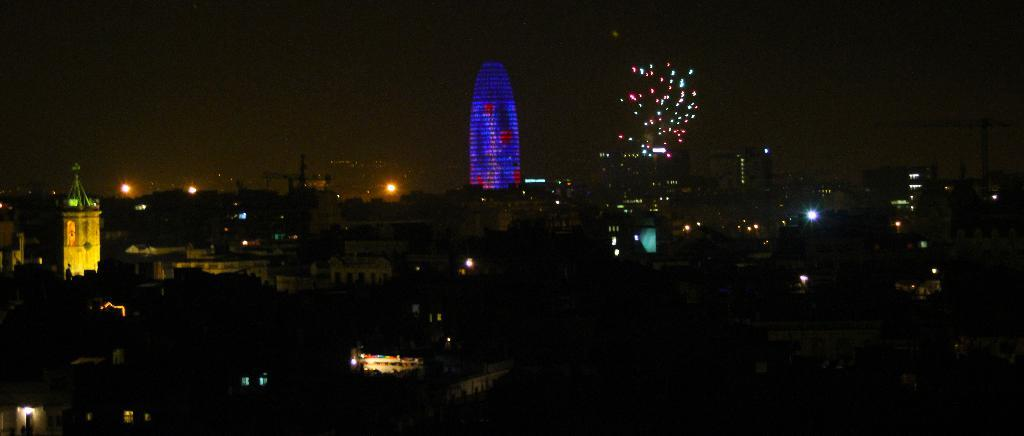What type of structures can be seen in the image? There are buildings in the image. What type of vegetation is present in the image? There are trees in the image. What can be seen illuminating the scene in the image? There are lights in the image. Can you tell me how many snails are crawling on the cloth in the image? There are no snails or cloth present in the image; it features buildings, trees, and lights. 